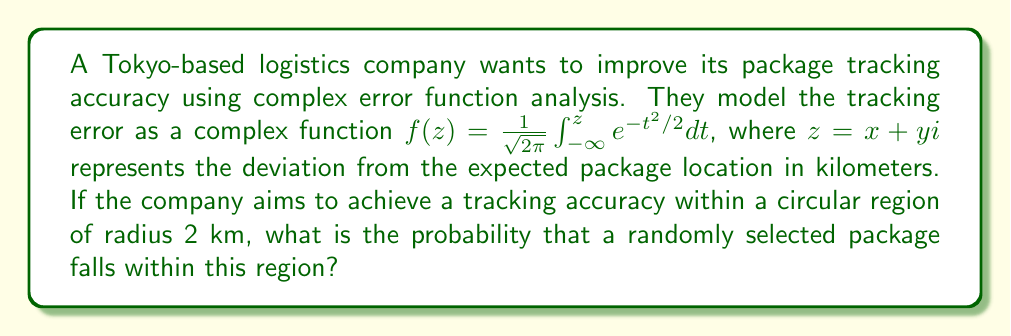What is the answer to this math problem? To solve this problem, we need to use the properties of the complex error function and its relationship to the probability distribution of package locations.

1. The given function $f(z)$ is the complex error function, also known as the Faddeeva function or the plasma dispersion function.

2. For a circular region in the complex plane, we need to consider the magnitude of $z$, which is $|z| = \sqrt{x^2 + y^2}$.

3. The probability that a package falls within a circular region of radius $r$ is given by:

   $$P(|z| \leq r) = 1 - e^{-r^2/2}$$

4. In this case, $r = 2$ km.

5. Substituting $r = 2$ into the probability formula:

   $$P(|z| \leq 2) = 1 - e^{-2^2/2} = 1 - e^{-2}$$

6. Calculate the result:
   
   $$1 - e^{-2} \approx 0.8646647167633873$$

7. Convert to a percentage:

   $$0.8646647167633873 \times 100\% \approx 86.47\%$$

Therefore, the probability that a randomly selected package falls within the circular region of radius 2 km is approximately 86.47%.
Answer: The probability is approximately 86.47%. 